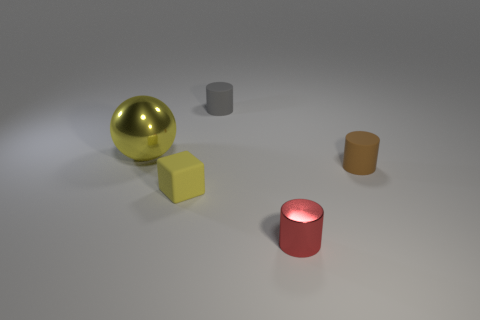Add 2 tiny rubber cylinders. How many objects exist? 7 Subtract all cylinders. How many objects are left? 2 Subtract 0 gray spheres. How many objects are left? 5 Subtract all tiny brown rubber cylinders. Subtract all small gray things. How many objects are left? 3 Add 1 yellow cubes. How many yellow cubes are left? 2 Add 5 tiny gray cylinders. How many tiny gray cylinders exist? 6 